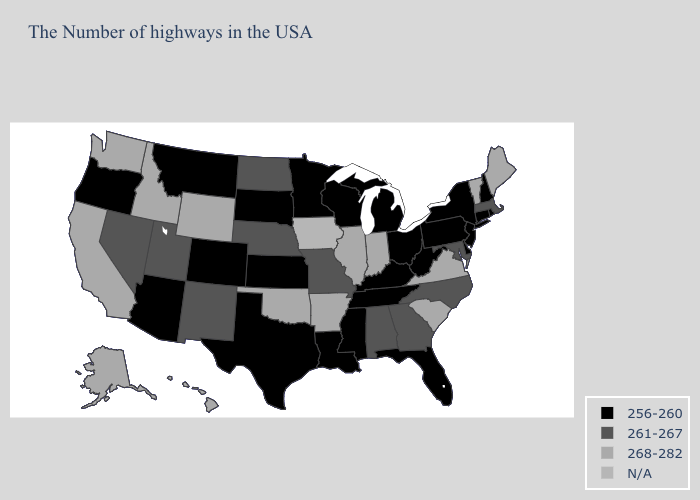Name the states that have a value in the range N/A?
Quick response, please. Iowa. Among the states that border Georgia , does Tennessee have the lowest value?
Concise answer only. Yes. Does South Carolina have the highest value in the South?
Concise answer only. Yes. Which states have the highest value in the USA?
Keep it brief. Maine, Vermont, Virginia, South Carolina, Indiana, Illinois, Arkansas, Oklahoma, Wyoming, Idaho, California, Washington, Alaska, Hawaii. Among the states that border Ohio , which have the lowest value?
Keep it brief. Pennsylvania, West Virginia, Michigan, Kentucky. Does the map have missing data?
Be succinct. Yes. Which states have the lowest value in the USA?
Concise answer only. Rhode Island, New Hampshire, Connecticut, New York, New Jersey, Delaware, Pennsylvania, West Virginia, Ohio, Florida, Michigan, Kentucky, Tennessee, Wisconsin, Mississippi, Louisiana, Minnesota, Kansas, Texas, South Dakota, Colorado, Montana, Arizona, Oregon. What is the value of California?
Answer briefly. 268-282. Is the legend a continuous bar?
Write a very short answer. No. How many symbols are there in the legend?
Keep it brief. 4. What is the value of Virginia?
Concise answer only. 268-282. Which states have the lowest value in the South?
Short answer required. Delaware, West Virginia, Florida, Kentucky, Tennessee, Mississippi, Louisiana, Texas. Name the states that have a value in the range 261-267?
Quick response, please. Massachusetts, Maryland, North Carolina, Georgia, Alabama, Missouri, Nebraska, North Dakota, New Mexico, Utah, Nevada. Does Wyoming have the highest value in the USA?
Short answer required. Yes. 